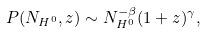<formula> <loc_0><loc_0><loc_500><loc_500>P ( N _ { H ^ { 0 } } , z ) \sim N _ { H ^ { 0 } } ^ { - \beta } ( 1 + z ) ^ { \gamma } ,</formula> 